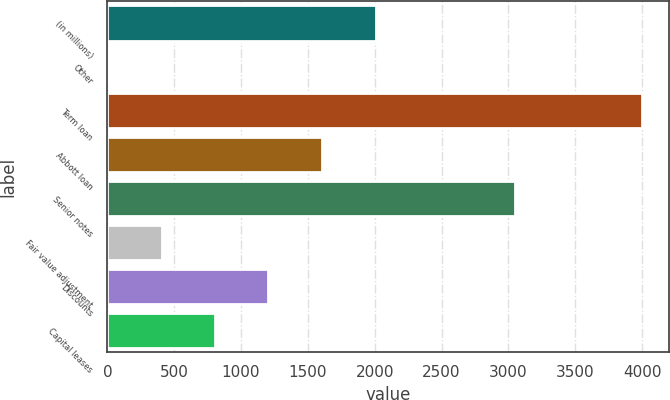<chart> <loc_0><loc_0><loc_500><loc_500><bar_chart><fcel>(in millions)<fcel>Other<fcel>Term loan<fcel>Abbott loan<fcel>Senior notes<fcel>Fair value adjustment<fcel>Discounts<fcel>Capital leases<nl><fcel>2007<fcel>6<fcel>4000<fcel>1603.6<fcel>3050<fcel>405.4<fcel>1204.2<fcel>804.8<nl></chart> 